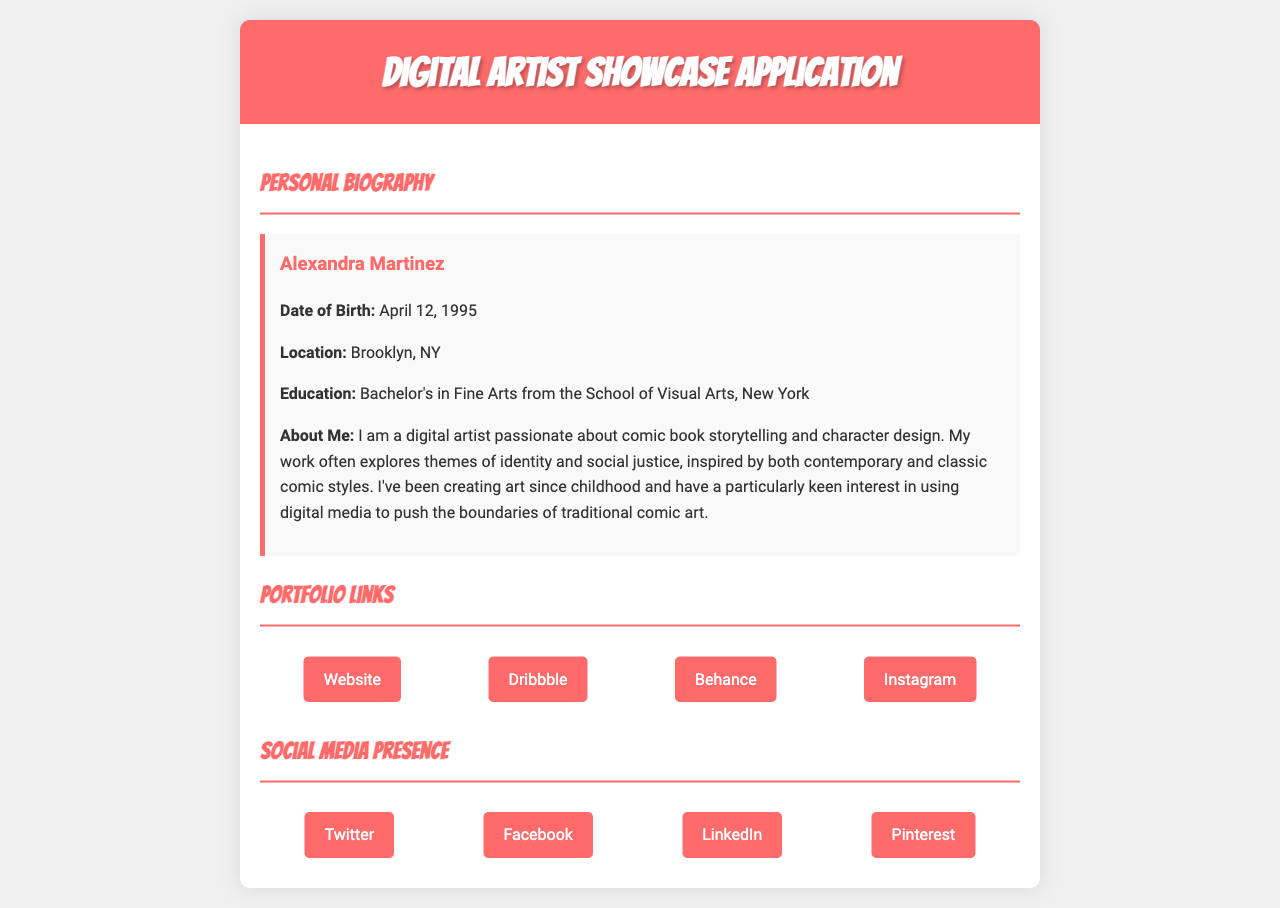What is the name of the artist? The document lists the artist's name prominently in the biography section.
Answer: Alexandra Martinez What is the date of birth of the artist? The artist's date of birth is included in the biography details.
Answer: April 12, 1995 Where is the artist located? The location of the artist is specified in the biography section.
Answer: Brooklyn, NY What degree does the artist hold? The educational background of the artist is outlined in the biography.
Answer: Bachelor's in Fine Arts What theme does the artist explore in their work? The biography indicates specific themes that influence the artist's creations.
Answer: Identity and social justice How many portfolio links are provided? The section lists multiple links to the artist's portfolio.
Answer: Four What social media platform is associated with the artist's presence apart from their website? The document mentions various social media platforms showcasing the artist's online presence.
Answer: Instagram Which platform can be used to view the artist's work? The portfolio section contains links to different platforms showcasing the artist's work.
Answer: Behance What is the primary focus of the artist's work? The biography elaborates on the main interests and focus areas of the artist.
Answer: Comic book storytelling and character design 